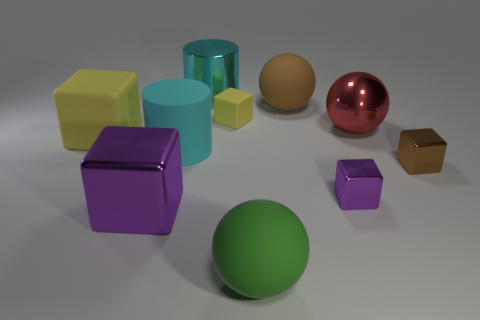Does the tiny matte thing have the same color as the metal cylinder?
Make the answer very short. No. There is a yellow rubber cube on the left side of the big cyan object to the left of the shiny cylinder; is there a big metal sphere that is in front of it?
Offer a very short reply. No. How many other objects are there of the same color as the big matte cylinder?
Keep it short and to the point. 1. How many large spheres are behind the brown metallic cube and to the left of the tiny purple cube?
Make the answer very short. 1. What is the shape of the brown metallic object?
Ensure brevity in your answer.  Cube. What number of other objects are there of the same material as the red sphere?
Give a very brief answer. 4. What color is the large matte thing that is in front of the purple cube that is in front of the purple metallic block that is behind the big purple metallic block?
Provide a short and direct response. Green. What is the material of the purple block that is the same size as the cyan metallic object?
Give a very brief answer. Metal. How many objects are either purple metallic objects left of the green rubber thing or brown objects?
Offer a terse response. 3. Are there any small purple shiny blocks?
Ensure brevity in your answer.  Yes. 